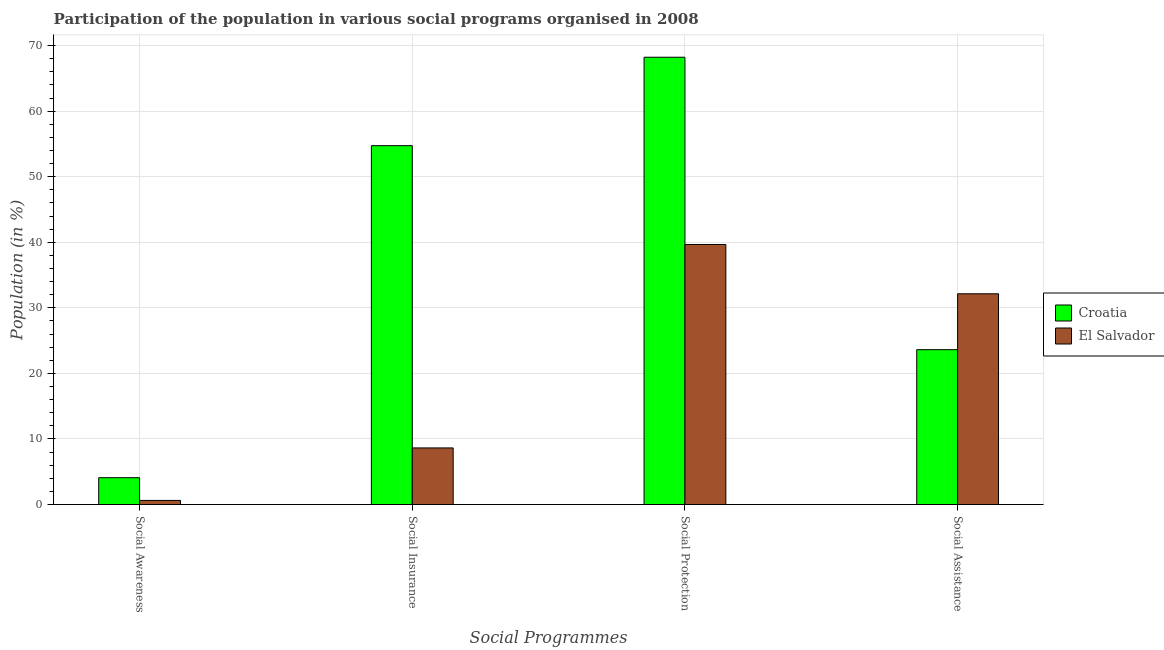How many different coloured bars are there?
Your answer should be compact. 2. How many groups of bars are there?
Give a very brief answer. 4. Are the number of bars per tick equal to the number of legend labels?
Your answer should be compact. Yes. Are the number of bars on each tick of the X-axis equal?
Give a very brief answer. Yes. How many bars are there on the 1st tick from the left?
Your response must be concise. 2. What is the label of the 4th group of bars from the left?
Give a very brief answer. Social Assistance. What is the participation of population in social awareness programs in El Salvador?
Your response must be concise. 0.63. Across all countries, what is the maximum participation of population in social assistance programs?
Keep it short and to the point. 32.15. Across all countries, what is the minimum participation of population in social insurance programs?
Your answer should be very brief. 8.63. In which country was the participation of population in social protection programs maximum?
Offer a very short reply. Croatia. In which country was the participation of population in social protection programs minimum?
Provide a short and direct response. El Salvador. What is the total participation of population in social protection programs in the graph?
Keep it short and to the point. 107.9. What is the difference between the participation of population in social awareness programs in El Salvador and that in Croatia?
Offer a very short reply. -3.47. What is the difference between the participation of population in social awareness programs in El Salvador and the participation of population in social protection programs in Croatia?
Provide a succinct answer. -67.6. What is the average participation of population in social assistance programs per country?
Provide a short and direct response. 27.89. What is the difference between the participation of population in social awareness programs and participation of population in social assistance programs in Croatia?
Your answer should be very brief. -19.53. In how many countries, is the participation of population in social protection programs greater than 46 %?
Make the answer very short. 1. What is the ratio of the participation of population in social assistance programs in Croatia to that in El Salvador?
Make the answer very short. 0.73. Is the difference between the participation of population in social awareness programs in Croatia and El Salvador greater than the difference between the participation of population in social protection programs in Croatia and El Salvador?
Provide a short and direct response. No. What is the difference between the highest and the second highest participation of population in social assistance programs?
Make the answer very short. 8.52. What is the difference between the highest and the lowest participation of population in social protection programs?
Your answer should be compact. 28.56. In how many countries, is the participation of population in social assistance programs greater than the average participation of population in social assistance programs taken over all countries?
Your answer should be very brief. 1. Is the sum of the participation of population in social insurance programs in Croatia and El Salvador greater than the maximum participation of population in social awareness programs across all countries?
Give a very brief answer. Yes. Is it the case that in every country, the sum of the participation of population in social insurance programs and participation of population in social assistance programs is greater than the sum of participation of population in social protection programs and participation of population in social awareness programs?
Make the answer very short. No. What does the 2nd bar from the left in Social Awareness represents?
Your answer should be compact. El Salvador. What does the 1st bar from the right in Social Protection represents?
Offer a very short reply. El Salvador. How many bars are there?
Provide a short and direct response. 8. Are all the bars in the graph horizontal?
Make the answer very short. No. How many countries are there in the graph?
Give a very brief answer. 2. Are the values on the major ticks of Y-axis written in scientific E-notation?
Your answer should be compact. No. Where does the legend appear in the graph?
Ensure brevity in your answer.  Center right. What is the title of the graph?
Ensure brevity in your answer.  Participation of the population in various social programs organised in 2008. What is the label or title of the X-axis?
Provide a short and direct response. Social Programmes. What is the label or title of the Y-axis?
Give a very brief answer. Population (in %). What is the Population (in %) in Croatia in Social Awareness?
Offer a terse response. 4.09. What is the Population (in %) in El Salvador in Social Awareness?
Provide a short and direct response. 0.63. What is the Population (in %) in Croatia in Social Insurance?
Your response must be concise. 54.74. What is the Population (in %) in El Salvador in Social Insurance?
Keep it short and to the point. 8.63. What is the Population (in %) of Croatia in Social Protection?
Your answer should be very brief. 68.23. What is the Population (in %) of El Salvador in Social Protection?
Your answer should be compact. 39.67. What is the Population (in %) in Croatia in Social Assistance?
Give a very brief answer. 23.63. What is the Population (in %) in El Salvador in Social Assistance?
Provide a succinct answer. 32.15. Across all Social Programmes, what is the maximum Population (in %) of Croatia?
Make the answer very short. 68.23. Across all Social Programmes, what is the maximum Population (in %) in El Salvador?
Provide a succinct answer. 39.67. Across all Social Programmes, what is the minimum Population (in %) of Croatia?
Your answer should be very brief. 4.09. Across all Social Programmes, what is the minimum Population (in %) of El Salvador?
Offer a very short reply. 0.63. What is the total Population (in %) in Croatia in the graph?
Offer a terse response. 150.7. What is the total Population (in %) of El Salvador in the graph?
Provide a short and direct response. 81.08. What is the difference between the Population (in %) of Croatia in Social Awareness and that in Social Insurance?
Make the answer very short. -50.65. What is the difference between the Population (in %) in El Salvador in Social Awareness and that in Social Insurance?
Your answer should be compact. -8.01. What is the difference between the Population (in %) in Croatia in Social Awareness and that in Social Protection?
Provide a short and direct response. -64.14. What is the difference between the Population (in %) of El Salvador in Social Awareness and that in Social Protection?
Provide a succinct answer. -39.04. What is the difference between the Population (in %) in Croatia in Social Awareness and that in Social Assistance?
Keep it short and to the point. -19.53. What is the difference between the Population (in %) of El Salvador in Social Awareness and that in Social Assistance?
Your answer should be very brief. -31.52. What is the difference between the Population (in %) of Croatia in Social Insurance and that in Social Protection?
Make the answer very short. -13.49. What is the difference between the Population (in %) in El Salvador in Social Insurance and that in Social Protection?
Your response must be concise. -31.03. What is the difference between the Population (in %) of Croatia in Social Insurance and that in Social Assistance?
Your answer should be very brief. 31.12. What is the difference between the Population (in %) in El Salvador in Social Insurance and that in Social Assistance?
Offer a very short reply. -23.51. What is the difference between the Population (in %) in Croatia in Social Protection and that in Social Assistance?
Ensure brevity in your answer.  44.61. What is the difference between the Population (in %) in El Salvador in Social Protection and that in Social Assistance?
Keep it short and to the point. 7.52. What is the difference between the Population (in %) of Croatia in Social Awareness and the Population (in %) of El Salvador in Social Insurance?
Offer a terse response. -4.54. What is the difference between the Population (in %) in Croatia in Social Awareness and the Population (in %) in El Salvador in Social Protection?
Offer a very short reply. -35.57. What is the difference between the Population (in %) in Croatia in Social Awareness and the Population (in %) in El Salvador in Social Assistance?
Your answer should be compact. -28.05. What is the difference between the Population (in %) of Croatia in Social Insurance and the Population (in %) of El Salvador in Social Protection?
Keep it short and to the point. 15.08. What is the difference between the Population (in %) in Croatia in Social Insurance and the Population (in %) in El Salvador in Social Assistance?
Your answer should be compact. 22.6. What is the difference between the Population (in %) in Croatia in Social Protection and the Population (in %) in El Salvador in Social Assistance?
Provide a short and direct response. 36.08. What is the average Population (in %) of Croatia per Social Programmes?
Ensure brevity in your answer.  37.67. What is the average Population (in %) of El Salvador per Social Programmes?
Offer a terse response. 20.27. What is the difference between the Population (in %) of Croatia and Population (in %) of El Salvador in Social Awareness?
Ensure brevity in your answer.  3.47. What is the difference between the Population (in %) of Croatia and Population (in %) of El Salvador in Social Insurance?
Your answer should be very brief. 46.11. What is the difference between the Population (in %) of Croatia and Population (in %) of El Salvador in Social Protection?
Your answer should be compact. 28.56. What is the difference between the Population (in %) of Croatia and Population (in %) of El Salvador in Social Assistance?
Your response must be concise. -8.52. What is the ratio of the Population (in %) in Croatia in Social Awareness to that in Social Insurance?
Your response must be concise. 0.07. What is the ratio of the Population (in %) of El Salvador in Social Awareness to that in Social Insurance?
Provide a short and direct response. 0.07. What is the ratio of the Population (in %) in Croatia in Social Awareness to that in Social Protection?
Your answer should be compact. 0.06. What is the ratio of the Population (in %) in El Salvador in Social Awareness to that in Social Protection?
Your answer should be compact. 0.02. What is the ratio of the Population (in %) of Croatia in Social Awareness to that in Social Assistance?
Your answer should be compact. 0.17. What is the ratio of the Population (in %) of El Salvador in Social Awareness to that in Social Assistance?
Offer a very short reply. 0.02. What is the ratio of the Population (in %) in Croatia in Social Insurance to that in Social Protection?
Provide a short and direct response. 0.8. What is the ratio of the Population (in %) in El Salvador in Social Insurance to that in Social Protection?
Your answer should be compact. 0.22. What is the ratio of the Population (in %) of Croatia in Social Insurance to that in Social Assistance?
Provide a short and direct response. 2.32. What is the ratio of the Population (in %) of El Salvador in Social Insurance to that in Social Assistance?
Ensure brevity in your answer.  0.27. What is the ratio of the Population (in %) in Croatia in Social Protection to that in Social Assistance?
Your response must be concise. 2.89. What is the ratio of the Population (in %) in El Salvador in Social Protection to that in Social Assistance?
Ensure brevity in your answer.  1.23. What is the difference between the highest and the second highest Population (in %) of Croatia?
Your answer should be compact. 13.49. What is the difference between the highest and the second highest Population (in %) in El Salvador?
Your response must be concise. 7.52. What is the difference between the highest and the lowest Population (in %) in Croatia?
Make the answer very short. 64.14. What is the difference between the highest and the lowest Population (in %) of El Salvador?
Your answer should be very brief. 39.04. 